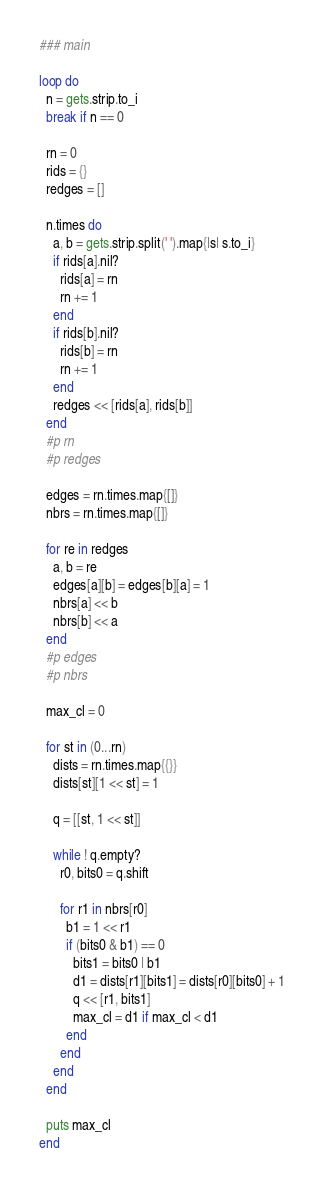<code> <loc_0><loc_0><loc_500><loc_500><_Ruby_>### main

loop do
  n = gets.strip.to_i
  break if n == 0

  rn = 0
  rids = {}
  redges = []

  n.times do
    a, b = gets.strip.split(' ').map{|s| s.to_i}
    if rids[a].nil?
      rids[a] = rn
      rn += 1
    end
    if rids[b].nil?
      rids[b] = rn
      rn += 1
    end
    redges << [rids[a], rids[b]]
  end
  #p rn
  #p redges

  edges = rn.times.map{[]}
  nbrs = rn.times.map{[]}

  for re in redges
    a, b = re
    edges[a][b] = edges[b][a] = 1
    nbrs[a] << b
    nbrs[b] << a
  end
  #p edges
  #p nbrs

  max_cl = 0

  for st in (0...rn)
    dists = rn.times.map{{}}
    dists[st][1 << st] = 1

    q = [[st, 1 << st]]

    while ! q.empty?
      r0, bits0 = q.shift

      for r1 in nbrs[r0]
        b1 = 1 << r1
        if (bits0 & b1) == 0
          bits1 = bits0 | b1
          d1 = dists[r1][bits1] = dists[r0][bits0] + 1
          q << [r1, bits1]
          max_cl = d1 if max_cl < d1
        end
      end
    end
  end

  puts max_cl
end</code> 